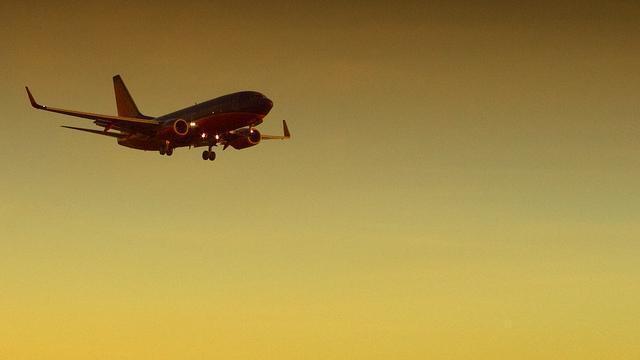How many cows are in the scene?
Give a very brief answer. 0. 